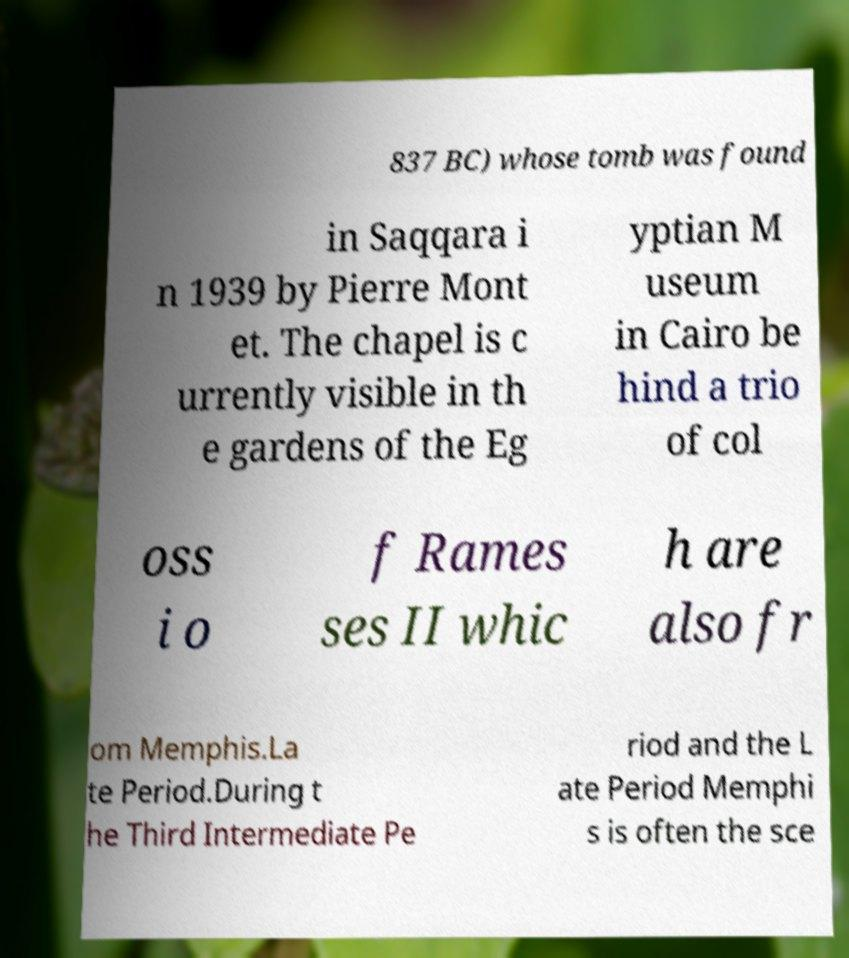Please identify and transcribe the text found in this image. 837 BC) whose tomb was found in Saqqara i n 1939 by Pierre Mont et. The chapel is c urrently visible in th e gardens of the Eg yptian M useum in Cairo be hind a trio of col oss i o f Rames ses II whic h are also fr om Memphis.La te Period.During t he Third Intermediate Pe riod and the L ate Period Memphi s is often the sce 